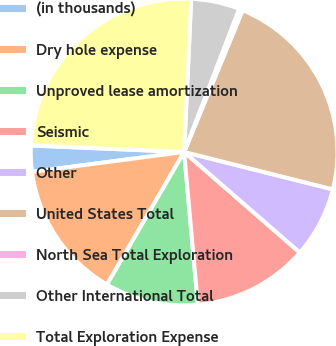<chart> <loc_0><loc_0><loc_500><loc_500><pie_chart><fcel>(in thousands)<fcel>Dry hole expense<fcel>Unproved lease amortization<fcel>Seismic<fcel>Other<fcel>United States Total<fcel>North Sea Total Exploration<fcel>Other International Total<fcel>Total Exploration Expense<nl><fcel>2.75%<fcel>14.54%<fcel>9.82%<fcel>12.18%<fcel>7.47%<fcel>22.69%<fcel>0.39%<fcel>5.11%<fcel>25.05%<nl></chart> 